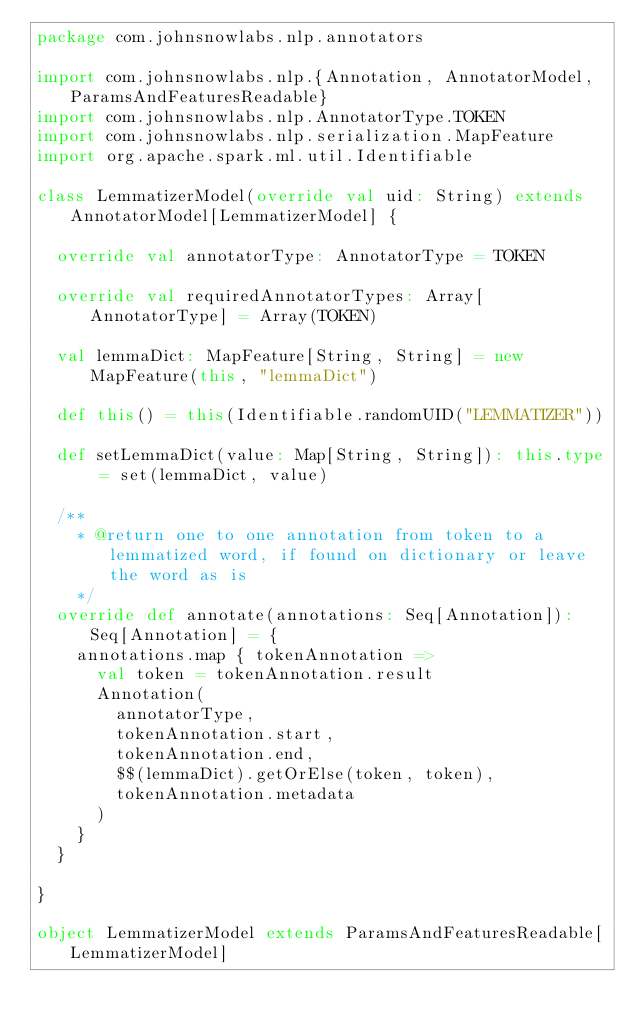Convert code to text. <code><loc_0><loc_0><loc_500><loc_500><_Scala_>package com.johnsnowlabs.nlp.annotators

import com.johnsnowlabs.nlp.{Annotation, AnnotatorModel, ParamsAndFeaturesReadable}
import com.johnsnowlabs.nlp.AnnotatorType.TOKEN
import com.johnsnowlabs.nlp.serialization.MapFeature
import org.apache.spark.ml.util.Identifiable

class LemmatizerModel(override val uid: String) extends AnnotatorModel[LemmatizerModel] {

  override val annotatorType: AnnotatorType = TOKEN

  override val requiredAnnotatorTypes: Array[AnnotatorType] = Array(TOKEN)

  val lemmaDict: MapFeature[String, String] = new MapFeature(this, "lemmaDict")

  def this() = this(Identifiable.randomUID("LEMMATIZER"))

  def setLemmaDict(value: Map[String, String]): this.type = set(lemmaDict, value)

  /**
    * @return one to one annotation from token to a lemmatized word, if found on dictionary or leave the word as is
    */
  override def annotate(annotations: Seq[Annotation]): Seq[Annotation] = {
    annotations.map { tokenAnnotation =>
      val token = tokenAnnotation.result
      Annotation(
        annotatorType,
        tokenAnnotation.start,
        tokenAnnotation.end,
        $$(lemmaDict).getOrElse(token, token),
        tokenAnnotation.metadata
      )
    }
  }

}

object LemmatizerModel extends ParamsAndFeaturesReadable[LemmatizerModel]</code> 